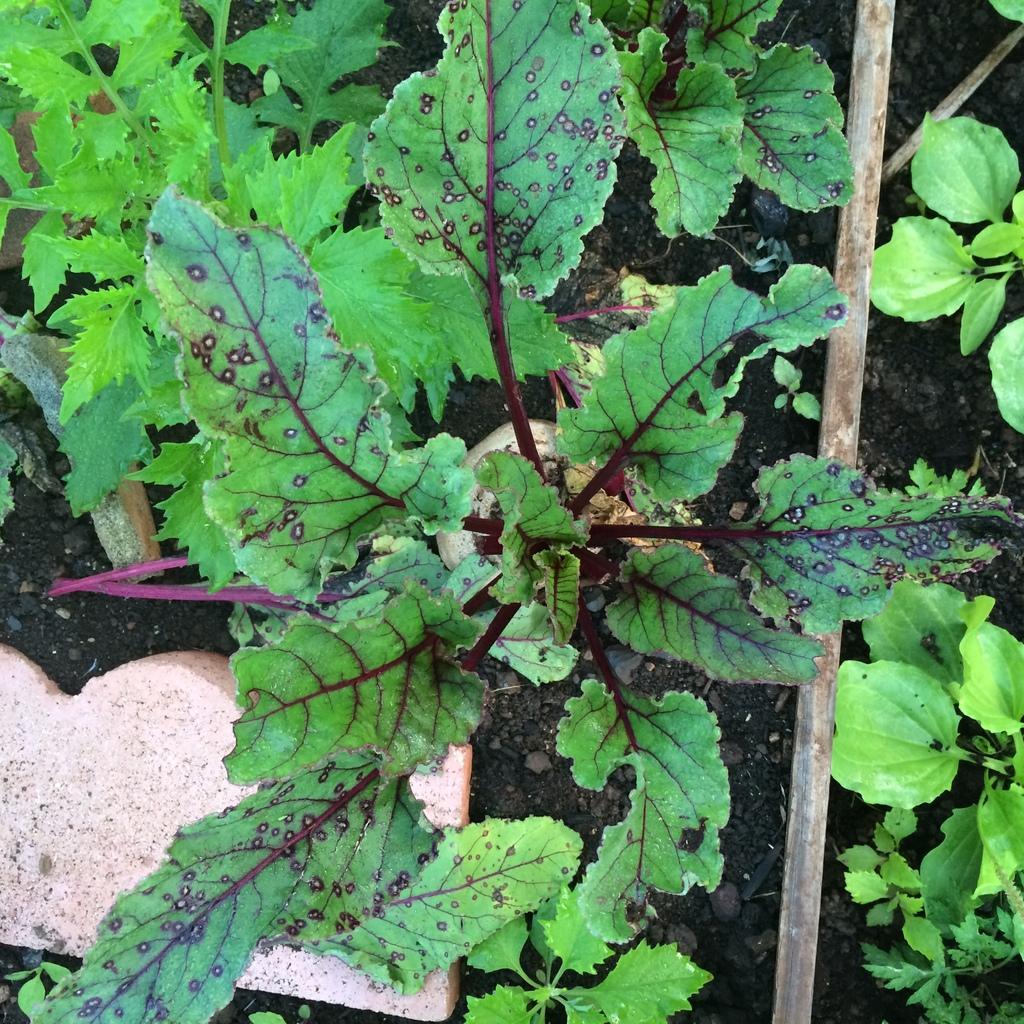How would you summarize this image in a sentence or two? On the right side, there are plants. On the left side, there are plants and an object which looks like a bread. 